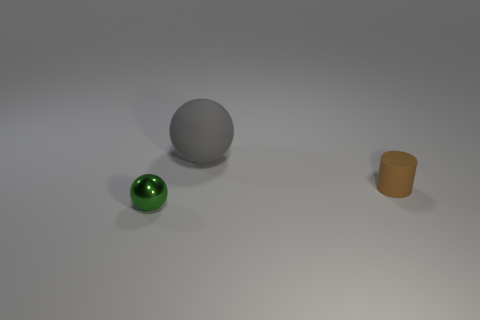Are there more rubber things that are in front of the tiny green metal object than blue cylinders?
Your answer should be very brief. No. How many other objects are the same size as the gray ball?
Your response must be concise. 0. What number of objects are both to the left of the tiny brown rubber thing and in front of the large matte sphere?
Your answer should be compact. 1. Is the sphere that is right of the green metallic object made of the same material as the brown cylinder?
Keep it short and to the point. Yes. There is a object behind the small object to the right of the thing in front of the small brown thing; what shape is it?
Your answer should be very brief. Sphere. Is the number of brown matte cylinders that are to the right of the brown object the same as the number of metallic objects behind the big thing?
Make the answer very short. Yes. What color is the matte thing that is the same size as the green metallic object?
Provide a succinct answer. Brown. What number of tiny things are either brown metallic cubes or green objects?
Your answer should be very brief. 1. There is a thing that is both to the left of the tiny brown cylinder and in front of the large gray thing; what is its material?
Make the answer very short. Metal. There is a object to the left of the gray ball; is its shape the same as the rubber thing left of the matte cylinder?
Offer a very short reply. Yes. 